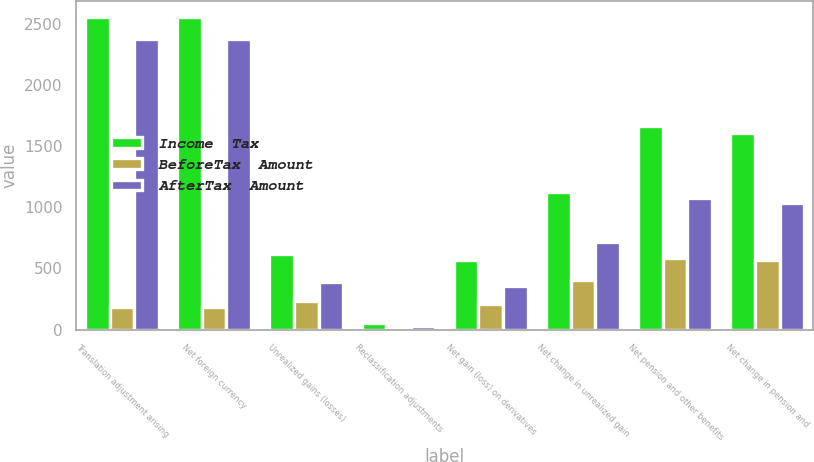<chart> <loc_0><loc_0><loc_500><loc_500><stacked_bar_chart><ecel><fcel>Translation adjustment arising<fcel>Net foreign currency<fcel>Unrealized gains (losses)<fcel>Reclassification adjustments<fcel>Net gain (loss) on derivatives<fcel>Net change in unrealized gain<fcel>Net pension and other benefits<fcel>Net change in pension and<nl><fcel>Income  Tax<fcel>2560<fcel>2560<fcel>620<fcel>50<fcel>570<fcel>1122<fcel>1666<fcel>1606<nl><fcel>BeforeTax  Amount<fcel>183<fcel>183<fcel>231<fcel>18<fcel>213<fcel>408<fcel>588<fcel>567<nl><fcel>AfterTax  Amount<fcel>2377<fcel>2377<fcel>389<fcel>32<fcel>357<fcel>714<fcel>1078<fcel>1039<nl></chart> 